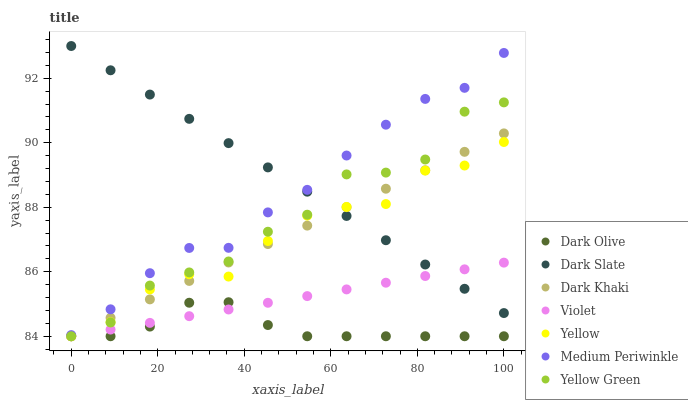Does Dark Olive have the minimum area under the curve?
Answer yes or no. Yes. Does Dark Slate have the maximum area under the curve?
Answer yes or no. Yes. Does Medium Periwinkle have the minimum area under the curve?
Answer yes or no. No. Does Medium Periwinkle have the maximum area under the curve?
Answer yes or no. No. Is Dark Slate the smoothest?
Answer yes or no. Yes. Is Yellow Green the roughest?
Answer yes or no. Yes. Is Dark Olive the smoothest?
Answer yes or no. No. Is Dark Olive the roughest?
Answer yes or no. No. Does Yellow Green have the lowest value?
Answer yes or no. Yes. Does Medium Periwinkle have the lowest value?
Answer yes or no. No. Does Dark Slate have the highest value?
Answer yes or no. Yes. Does Medium Periwinkle have the highest value?
Answer yes or no. No. Is Yellow Green less than Medium Periwinkle?
Answer yes or no. Yes. Is Medium Periwinkle greater than Dark Olive?
Answer yes or no. Yes. Does Violet intersect Dark Khaki?
Answer yes or no. Yes. Is Violet less than Dark Khaki?
Answer yes or no. No. Is Violet greater than Dark Khaki?
Answer yes or no. No. Does Yellow Green intersect Medium Periwinkle?
Answer yes or no. No. 